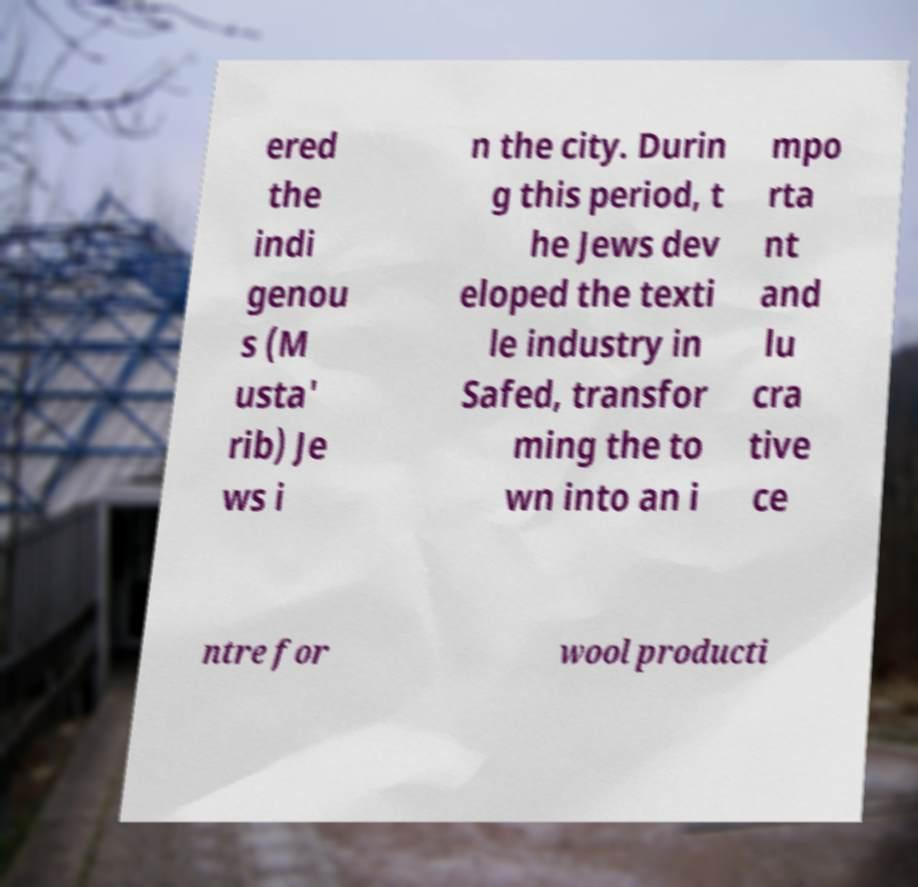What messages or text are displayed in this image? I need them in a readable, typed format. ered the indi genou s (M usta' rib) Je ws i n the city. Durin g this period, t he Jews dev eloped the texti le industry in Safed, transfor ming the to wn into an i mpo rta nt and lu cra tive ce ntre for wool producti 